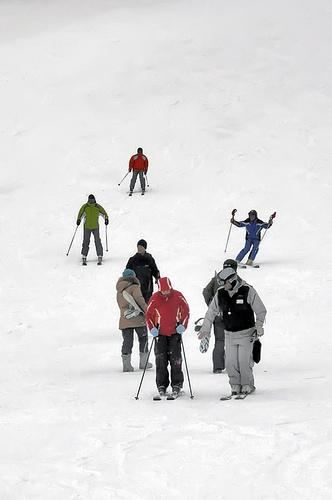What is the man in grey pants doing?

Choices:
A) coaching
B) joking
C) complaining
D) singing coaching 